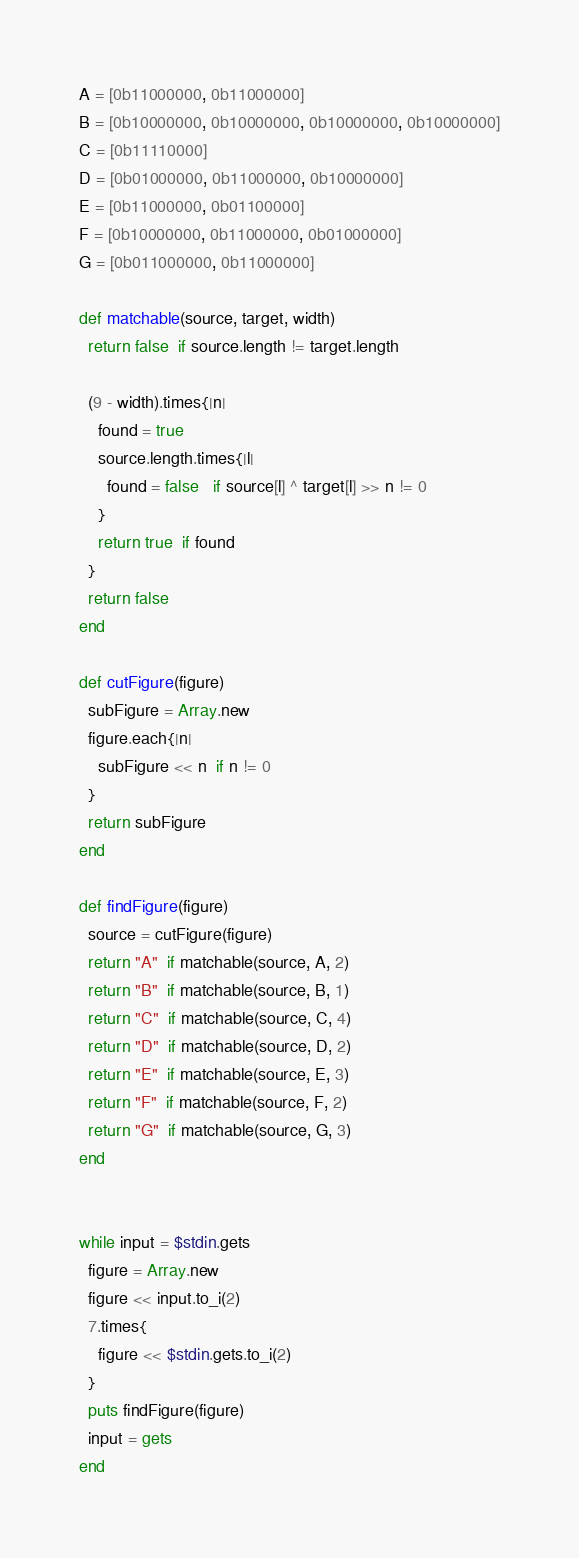<code> <loc_0><loc_0><loc_500><loc_500><_Ruby_>A = [0b11000000, 0b11000000]
B = [0b10000000, 0b10000000, 0b10000000, 0b10000000]
C = [0b11110000]
D = [0b01000000, 0b11000000, 0b10000000]
E = [0b11000000, 0b01100000]
F = [0b10000000, 0b11000000, 0b01000000]
G = [0b011000000, 0b11000000]

def matchable(source, target, width)
  return false  if source.length != target.length
  
  (9 - width).times{|n|
    found = true
    source.length.times{|l|
      found = false   if source[l] ^ target[l] >> n != 0
    }
    return true  if found
  }
  return false
end

def cutFigure(figure)
  subFigure = Array.new
  figure.each{|n|
    subFigure << n  if n != 0
  }
  return subFigure
end

def findFigure(figure)
  source = cutFigure(figure)
  return "A"  if matchable(source, A, 2)
  return "B"  if matchable(source, B, 1)
  return "C"  if matchable(source, C, 4)
  return "D"  if matchable(source, D, 2)
  return "E"  if matchable(source, E, 3)
  return "F"  if matchable(source, F, 2)
  return "G"  if matchable(source, G, 3)
end


while input = $stdin.gets
  figure = Array.new
  figure << input.to_i(2)
  7.times{
    figure << $stdin.gets.to_i(2)
  }
  puts findFigure(figure)
  input = gets
end</code> 